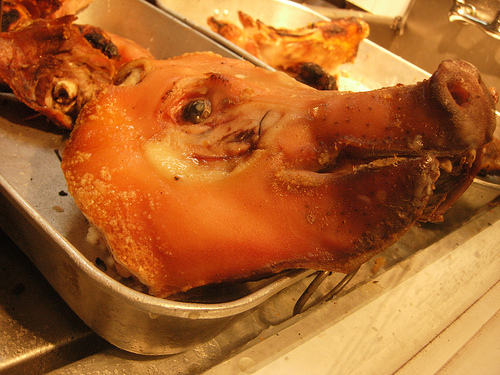<image>
Is there a pig head in the pan? Yes. The pig head is contained within or inside the pan, showing a containment relationship. 